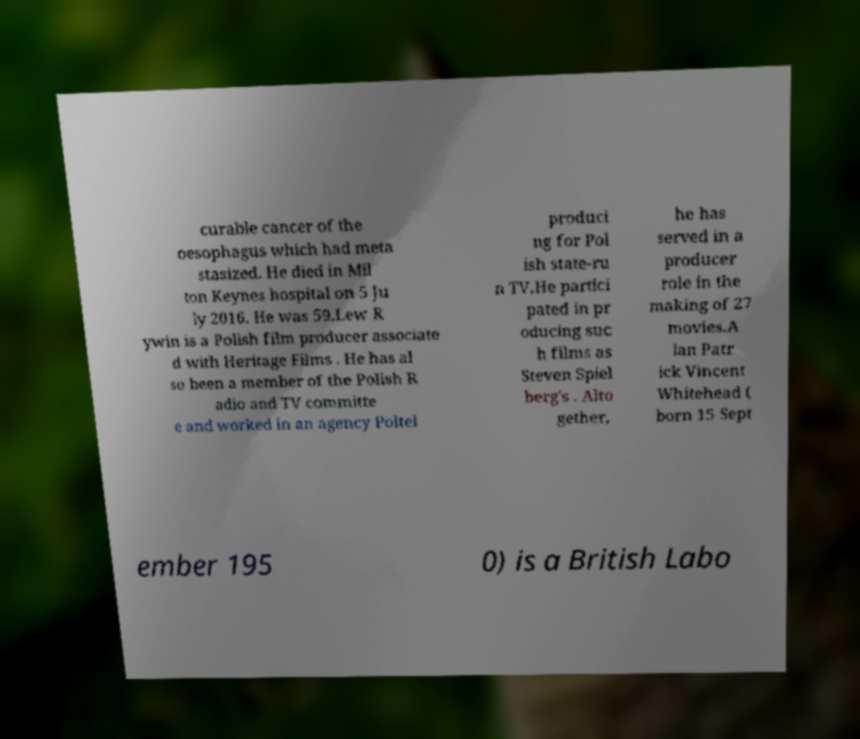Can you read and provide the text displayed in the image?This photo seems to have some interesting text. Can you extract and type it out for me? curable cancer of the oesophagus which had meta stasized. He died in Mil ton Keynes hospital on 5 Ju ly 2016. He was 59.Lew R ywin is a Polish film producer associate d with Heritage Films . He has al so been a member of the Polish R adio and TV committe e and worked in an agency Poltel produci ng for Pol ish state-ru n TV.He partici pated in pr oducing suc h films as Steven Spiel berg's . Alto gether, he has served in a producer role in the making of 27 movies.A lan Patr ick Vincent Whitehead ( born 15 Sept ember 195 0) is a British Labo 